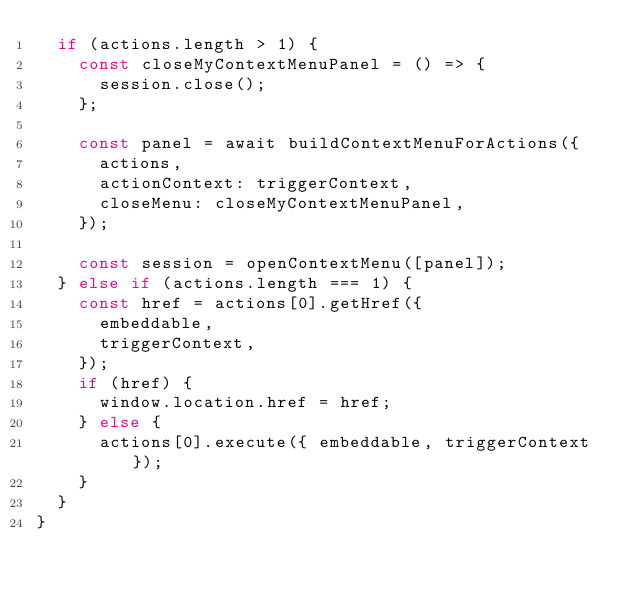Convert code to text. <code><loc_0><loc_0><loc_500><loc_500><_TypeScript_>  if (actions.length > 1) {
    const closeMyContextMenuPanel = () => {
      session.close();
    };

    const panel = await buildContextMenuForActions({
      actions,
      actionContext: triggerContext,
      closeMenu: closeMyContextMenuPanel,
    });

    const session = openContextMenu([panel]);
  } else if (actions.length === 1) {
    const href = actions[0].getHref({
      embeddable,
      triggerContext,
    });
    if (href) {
      window.location.href = href;
    } else {
      actions[0].execute({ embeddable, triggerContext });
    }
  }
}
</code> 